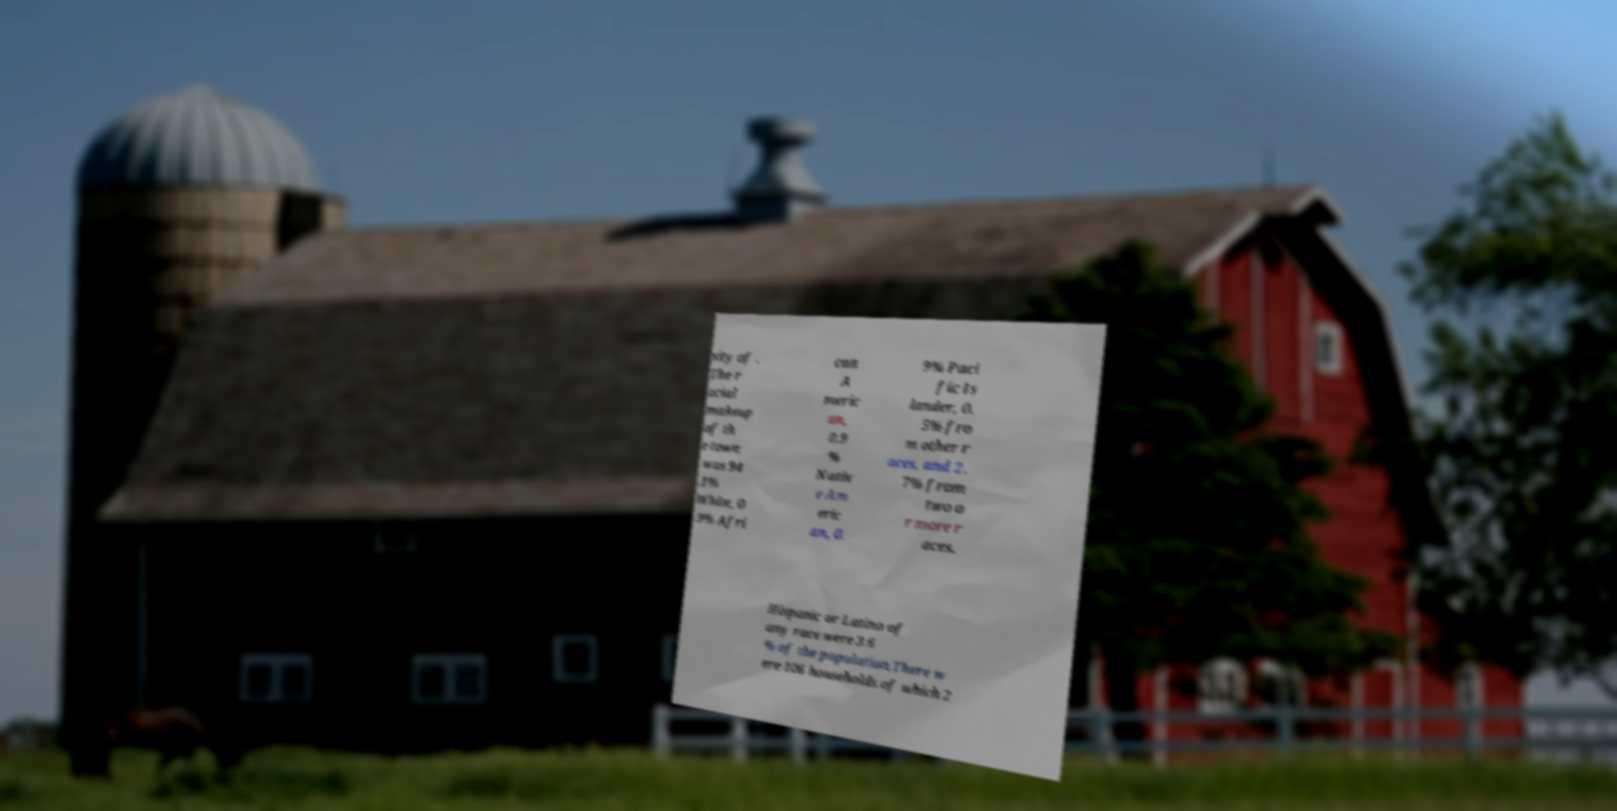I need the written content from this picture converted into text. Can you do that? sity of . The r acial makeup of th e town was 94 .1% White, 0 .9% Afri can A meric an, 0.9 % Nativ e Am eric an, 0. 9% Paci fic Is lander, 0. 5% fro m other r aces, and 2. 7% from two o r more r aces. Hispanic or Latino of any race were 3.6 % of the population.There w ere 106 households of which 2 